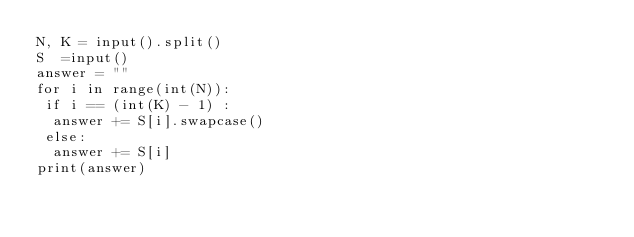Convert code to text. <code><loc_0><loc_0><loc_500><loc_500><_Python_>N, K = input().split()
S  =input()
answer = ""
for i in range(int(N)):
 if i == (int(K) - 1) :
  answer += S[i].swapcase()
 else:
  answer += S[i]
print(answer)
</code> 